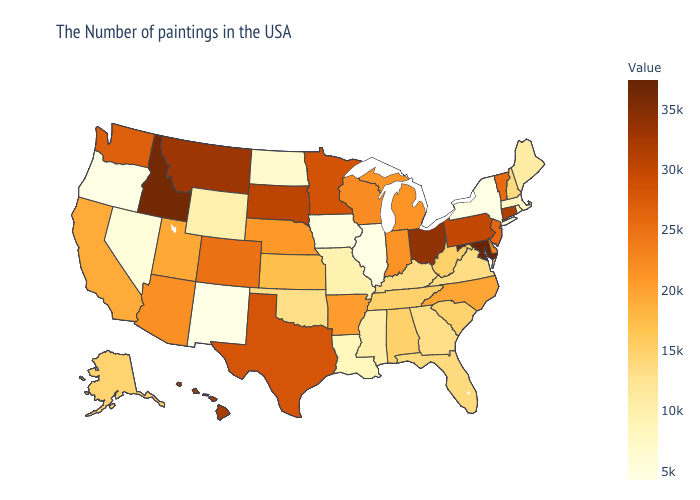Does New Jersey have a lower value than Arizona?
Be succinct. No. Does the map have missing data?
Short answer required. No. Among the states that border Wyoming , does Idaho have the highest value?
Concise answer only. Yes. Is the legend a continuous bar?
Short answer required. Yes. Among the states that border Connecticut , which have the highest value?
Be succinct. Rhode Island. Which states have the lowest value in the South?
Give a very brief answer. Louisiana. Among the states that border Pennsylvania , which have the lowest value?
Short answer required. New York. 